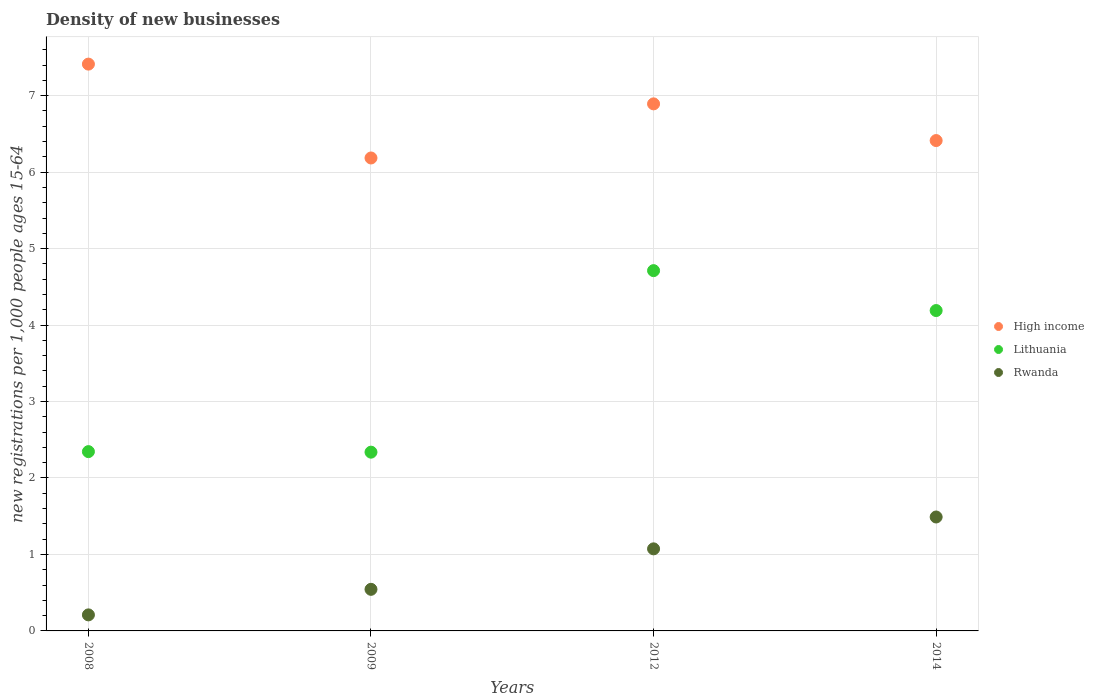How many different coloured dotlines are there?
Make the answer very short. 3. What is the number of new registrations in High income in 2008?
Provide a succinct answer. 7.41. Across all years, what is the maximum number of new registrations in Lithuania?
Make the answer very short. 4.71. Across all years, what is the minimum number of new registrations in High income?
Make the answer very short. 6.19. In which year was the number of new registrations in Rwanda minimum?
Your answer should be compact. 2008. What is the total number of new registrations in Lithuania in the graph?
Keep it short and to the point. 13.58. What is the difference between the number of new registrations in Lithuania in 2008 and that in 2012?
Your answer should be very brief. -2.37. What is the difference between the number of new registrations in Rwanda in 2014 and the number of new registrations in High income in 2009?
Offer a terse response. -4.7. What is the average number of new registrations in Lithuania per year?
Give a very brief answer. 3.4. In the year 2012, what is the difference between the number of new registrations in High income and number of new registrations in Lithuania?
Make the answer very short. 2.18. In how many years, is the number of new registrations in High income greater than 2.2?
Your answer should be compact. 4. What is the ratio of the number of new registrations in High income in 2008 to that in 2012?
Your response must be concise. 1.08. Is the number of new registrations in High income in 2009 less than that in 2014?
Provide a succinct answer. Yes. Is the difference between the number of new registrations in High income in 2009 and 2014 greater than the difference between the number of new registrations in Lithuania in 2009 and 2014?
Offer a very short reply. Yes. What is the difference between the highest and the second highest number of new registrations in Rwanda?
Provide a succinct answer. 0.42. What is the difference between the highest and the lowest number of new registrations in Rwanda?
Make the answer very short. 1.28. In how many years, is the number of new registrations in High income greater than the average number of new registrations in High income taken over all years?
Keep it short and to the point. 2. Is the sum of the number of new registrations in Lithuania in 2009 and 2014 greater than the maximum number of new registrations in High income across all years?
Provide a short and direct response. No. Is it the case that in every year, the sum of the number of new registrations in Lithuania and number of new registrations in High income  is greater than the number of new registrations in Rwanda?
Give a very brief answer. Yes. Does the number of new registrations in Rwanda monotonically increase over the years?
Your answer should be compact. Yes. Is the number of new registrations in High income strictly greater than the number of new registrations in Rwanda over the years?
Your answer should be compact. Yes. Is the number of new registrations in Rwanda strictly less than the number of new registrations in High income over the years?
Provide a short and direct response. Yes. How many dotlines are there?
Offer a terse response. 3. Does the graph contain any zero values?
Provide a short and direct response. No. Does the graph contain grids?
Offer a terse response. Yes. Where does the legend appear in the graph?
Provide a succinct answer. Center right. What is the title of the graph?
Keep it short and to the point. Density of new businesses. What is the label or title of the X-axis?
Keep it short and to the point. Years. What is the label or title of the Y-axis?
Ensure brevity in your answer.  New registrations per 1,0 people ages 15-64. What is the new registrations per 1,000 people ages 15-64 in High income in 2008?
Keep it short and to the point. 7.41. What is the new registrations per 1,000 people ages 15-64 in Lithuania in 2008?
Your response must be concise. 2.34. What is the new registrations per 1,000 people ages 15-64 of Rwanda in 2008?
Your response must be concise. 0.21. What is the new registrations per 1,000 people ages 15-64 in High income in 2009?
Make the answer very short. 6.19. What is the new registrations per 1,000 people ages 15-64 of Lithuania in 2009?
Your answer should be compact. 2.34. What is the new registrations per 1,000 people ages 15-64 in Rwanda in 2009?
Make the answer very short. 0.54. What is the new registrations per 1,000 people ages 15-64 of High income in 2012?
Keep it short and to the point. 6.89. What is the new registrations per 1,000 people ages 15-64 in Lithuania in 2012?
Make the answer very short. 4.71. What is the new registrations per 1,000 people ages 15-64 of Rwanda in 2012?
Ensure brevity in your answer.  1.07. What is the new registrations per 1,000 people ages 15-64 in High income in 2014?
Your response must be concise. 6.41. What is the new registrations per 1,000 people ages 15-64 of Lithuania in 2014?
Keep it short and to the point. 4.19. What is the new registrations per 1,000 people ages 15-64 in Rwanda in 2014?
Keep it short and to the point. 1.49. Across all years, what is the maximum new registrations per 1,000 people ages 15-64 of High income?
Give a very brief answer. 7.41. Across all years, what is the maximum new registrations per 1,000 people ages 15-64 in Lithuania?
Make the answer very short. 4.71. Across all years, what is the maximum new registrations per 1,000 people ages 15-64 of Rwanda?
Make the answer very short. 1.49. Across all years, what is the minimum new registrations per 1,000 people ages 15-64 in High income?
Provide a short and direct response. 6.19. Across all years, what is the minimum new registrations per 1,000 people ages 15-64 in Lithuania?
Provide a succinct answer. 2.34. Across all years, what is the minimum new registrations per 1,000 people ages 15-64 of Rwanda?
Make the answer very short. 0.21. What is the total new registrations per 1,000 people ages 15-64 in High income in the graph?
Offer a very short reply. 26.9. What is the total new registrations per 1,000 people ages 15-64 of Lithuania in the graph?
Give a very brief answer. 13.58. What is the total new registrations per 1,000 people ages 15-64 in Rwanda in the graph?
Offer a terse response. 3.32. What is the difference between the new registrations per 1,000 people ages 15-64 of High income in 2008 and that in 2009?
Keep it short and to the point. 1.23. What is the difference between the new registrations per 1,000 people ages 15-64 in Lithuania in 2008 and that in 2009?
Your answer should be very brief. 0.01. What is the difference between the new registrations per 1,000 people ages 15-64 in Rwanda in 2008 and that in 2009?
Provide a succinct answer. -0.33. What is the difference between the new registrations per 1,000 people ages 15-64 in High income in 2008 and that in 2012?
Your answer should be very brief. 0.52. What is the difference between the new registrations per 1,000 people ages 15-64 in Lithuania in 2008 and that in 2012?
Ensure brevity in your answer.  -2.37. What is the difference between the new registrations per 1,000 people ages 15-64 of Rwanda in 2008 and that in 2012?
Provide a short and direct response. -0.86. What is the difference between the new registrations per 1,000 people ages 15-64 of Lithuania in 2008 and that in 2014?
Provide a succinct answer. -1.84. What is the difference between the new registrations per 1,000 people ages 15-64 in Rwanda in 2008 and that in 2014?
Ensure brevity in your answer.  -1.28. What is the difference between the new registrations per 1,000 people ages 15-64 in High income in 2009 and that in 2012?
Keep it short and to the point. -0.71. What is the difference between the new registrations per 1,000 people ages 15-64 of Lithuania in 2009 and that in 2012?
Provide a short and direct response. -2.37. What is the difference between the new registrations per 1,000 people ages 15-64 in Rwanda in 2009 and that in 2012?
Ensure brevity in your answer.  -0.53. What is the difference between the new registrations per 1,000 people ages 15-64 in High income in 2009 and that in 2014?
Provide a short and direct response. -0.23. What is the difference between the new registrations per 1,000 people ages 15-64 in Lithuania in 2009 and that in 2014?
Offer a very short reply. -1.85. What is the difference between the new registrations per 1,000 people ages 15-64 of Rwanda in 2009 and that in 2014?
Keep it short and to the point. -0.95. What is the difference between the new registrations per 1,000 people ages 15-64 of High income in 2012 and that in 2014?
Your response must be concise. 0.48. What is the difference between the new registrations per 1,000 people ages 15-64 in Lithuania in 2012 and that in 2014?
Your answer should be compact. 0.52. What is the difference between the new registrations per 1,000 people ages 15-64 of Rwanda in 2012 and that in 2014?
Give a very brief answer. -0.42. What is the difference between the new registrations per 1,000 people ages 15-64 of High income in 2008 and the new registrations per 1,000 people ages 15-64 of Lithuania in 2009?
Your answer should be compact. 5.08. What is the difference between the new registrations per 1,000 people ages 15-64 in High income in 2008 and the new registrations per 1,000 people ages 15-64 in Rwanda in 2009?
Provide a short and direct response. 6.87. What is the difference between the new registrations per 1,000 people ages 15-64 of Lithuania in 2008 and the new registrations per 1,000 people ages 15-64 of Rwanda in 2009?
Offer a terse response. 1.8. What is the difference between the new registrations per 1,000 people ages 15-64 in High income in 2008 and the new registrations per 1,000 people ages 15-64 in Lithuania in 2012?
Keep it short and to the point. 2.7. What is the difference between the new registrations per 1,000 people ages 15-64 in High income in 2008 and the new registrations per 1,000 people ages 15-64 in Rwanda in 2012?
Keep it short and to the point. 6.34. What is the difference between the new registrations per 1,000 people ages 15-64 in Lithuania in 2008 and the new registrations per 1,000 people ages 15-64 in Rwanda in 2012?
Offer a very short reply. 1.27. What is the difference between the new registrations per 1,000 people ages 15-64 of High income in 2008 and the new registrations per 1,000 people ages 15-64 of Lithuania in 2014?
Keep it short and to the point. 3.22. What is the difference between the new registrations per 1,000 people ages 15-64 of High income in 2008 and the new registrations per 1,000 people ages 15-64 of Rwanda in 2014?
Your response must be concise. 5.92. What is the difference between the new registrations per 1,000 people ages 15-64 in Lithuania in 2008 and the new registrations per 1,000 people ages 15-64 in Rwanda in 2014?
Your answer should be compact. 0.85. What is the difference between the new registrations per 1,000 people ages 15-64 in High income in 2009 and the new registrations per 1,000 people ages 15-64 in Lithuania in 2012?
Your answer should be very brief. 1.47. What is the difference between the new registrations per 1,000 people ages 15-64 of High income in 2009 and the new registrations per 1,000 people ages 15-64 of Rwanda in 2012?
Keep it short and to the point. 5.11. What is the difference between the new registrations per 1,000 people ages 15-64 in Lithuania in 2009 and the new registrations per 1,000 people ages 15-64 in Rwanda in 2012?
Keep it short and to the point. 1.26. What is the difference between the new registrations per 1,000 people ages 15-64 of High income in 2009 and the new registrations per 1,000 people ages 15-64 of Lithuania in 2014?
Your response must be concise. 2. What is the difference between the new registrations per 1,000 people ages 15-64 in High income in 2009 and the new registrations per 1,000 people ages 15-64 in Rwanda in 2014?
Offer a very short reply. 4.7. What is the difference between the new registrations per 1,000 people ages 15-64 in Lithuania in 2009 and the new registrations per 1,000 people ages 15-64 in Rwanda in 2014?
Offer a very short reply. 0.85. What is the difference between the new registrations per 1,000 people ages 15-64 of High income in 2012 and the new registrations per 1,000 people ages 15-64 of Lithuania in 2014?
Your answer should be compact. 2.7. What is the difference between the new registrations per 1,000 people ages 15-64 in High income in 2012 and the new registrations per 1,000 people ages 15-64 in Rwanda in 2014?
Keep it short and to the point. 5.4. What is the difference between the new registrations per 1,000 people ages 15-64 in Lithuania in 2012 and the new registrations per 1,000 people ages 15-64 in Rwanda in 2014?
Your answer should be very brief. 3.22. What is the average new registrations per 1,000 people ages 15-64 in High income per year?
Keep it short and to the point. 6.73. What is the average new registrations per 1,000 people ages 15-64 in Lithuania per year?
Your response must be concise. 3.4. What is the average new registrations per 1,000 people ages 15-64 of Rwanda per year?
Keep it short and to the point. 0.83. In the year 2008, what is the difference between the new registrations per 1,000 people ages 15-64 of High income and new registrations per 1,000 people ages 15-64 of Lithuania?
Ensure brevity in your answer.  5.07. In the year 2008, what is the difference between the new registrations per 1,000 people ages 15-64 in High income and new registrations per 1,000 people ages 15-64 in Rwanda?
Offer a terse response. 7.2. In the year 2008, what is the difference between the new registrations per 1,000 people ages 15-64 of Lithuania and new registrations per 1,000 people ages 15-64 of Rwanda?
Your answer should be very brief. 2.14. In the year 2009, what is the difference between the new registrations per 1,000 people ages 15-64 in High income and new registrations per 1,000 people ages 15-64 in Lithuania?
Ensure brevity in your answer.  3.85. In the year 2009, what is the difference between the new registrations per 1,000 people ages 15-64 in High income and new registrations per 1,000 people ages 15-64 in Rwanda?
Offer a terse response. 5.64. In the year 2009, what is the difference between the new registrations per 1,000 people ages 15-64 in Lithuania and new registrations per 1,000 people ages 15-64 in Rwanda?
Make the answer very short. 1.79. In the year 2012, what is the difference between the new registrations per 1,000 people ages 15-64 of High income and new registrations per 1,000 people ages 15-64 of Lithuania?
Your response must be concise. 2.18. In the year 2012, what is the difference between the new registrations per 1,000 people ages 15-64 in High income and new registrations per 1,000 people ages 15-64 in Rwanda?
Give a very brief answer. 5.82. In the year 2012, what is the difference between the new registrations per 1,000 people ages 15-64 of Lithuania and new registrations per 1,000 people ages 15-64 of Rwanda?
Offer a very short reply. 3.64. In the year 2014, what is the difference between the new registrations per 1,000 people ages 15-64 of High income and new registrations per 1,000 people ages 15-64 of Lithuania?
Offer a very short reply. 2.22. In the year 2014, what is the difference between the new registrations per 1,000 people ages 15-64 of High income and new registrations per 1,000 people ages 15-64 of Rwanda?
Keep it short and to the point. 4.92. In the year 2014, what is the difference between the new registrations per 1,000 people ages 15-64 in Lithuania and new registrations per 1,000 people ages 15-64 in Rwanda?
Your answer should be very brief. 2.7. What is the ratio of the new registrations per 1,000 people ages 15-64 in High income in 2008 to that in 2009?
Your answer should be compact. 1.2. What is the ratio of the new registrations per 1,000 people ages 15-64 of Lithuania in 2008 to that in 2009?
Provide a short and direct response. 1. What is the ratio of the new registrations per 1,000 people ages 15-64 of Rwanda in 2008 to that in 2009?
Your answer should be very brief. 0.39. What is the ratio of the new registrations per 1,000 people ages 15-64 in High income in 2008 to that in 2012?
Your answer should be very brief. 1.08. What is the ratio of the new registrations per 1,000 people ages 15-64 in Lithuania in 2008 to that in 2012?
Your answer should be compact. 0.5. What is the ratio of the new registrations per 1,000 people ages 15-64 in Rwanda in 2008 to that in 2012?
Provide a succinct answer. 0.2. What is the ratio of the new registrations per 1,000 people ages 15-64 of High income in 2008 to that in 2014?
Your answer should be very brief. 1.16. What is the ratio of the new registrations per 1,000 people ages 15-64 in Lithuania in 2008 to that in 2014?
Provide a succinct answer. 0.56. What is the ratio of the new registrations per 1,000 people ages 15-64 in Rwanda in 2008 to that in 2014?
Keep it short and to the point. 0.14. What is the ratio of the new registrations per 1,000 people ages 15-64 in High income in 2009 to that in 2012?
Provide a short and direct response. 0.9. What is the ratio of the new registrations per 1,000 people ages 15-64 in Lithuania in 2009 to that in 2012?
Provide a short and direct response. 0.5. What is the ratio of the new registrations per 1,000 people ages 15-64 in Rwanda in 2009 to that in 2012?
Make the answer very short. 0.51. What is the ratio of the new registrations per 1,000 people ages 15-64 of High income in 2009 to that in 2014?
Offer a terse response. 0.96. What is the ratio of the new registrations per 1,000 people ages 15-64 in Lithuania in 2009 to that in 2014?
Provide a short and direct response. 0.56. What is the ratio of the new registrations per 1,000 people ages 15-64 in Rwanda in 2009 to that in 2014?
Ensure brevity in your answer.  0.37. What is the ratio of the new registrations per 1,000 people ages 15-64 of High income in 2012 to that in 2014?
Ensure brevity in your answer.  1.07. What is the ratio of the new registrations per 1,000 people ages 15-64 of Lithuania in 2012 to that in 2014?
Your answer should be very brief. 1.12. What is the ratio of the new registrations per 1,000 people ages 15-64 in Rwanda in 2012 to that in 2014?
Keep it short and to the point. 0.72. What is the difference between the highest and the second highest new registrations per 1,000 people ages 15-64 of High income?
Offer a terse response. 0.52. What is the difference between the highest and the second highest new registrations per 1,000 people ages 15-64 in Lithuania?
Your response must be concise. 0.52. What is the difference between the highest and the second highest new registrations per 1,000 people ages 15-64 in Rwanda?
Your answer should be very brief. 0.42. What is the difference between the highest and the lowest new registrations per 1,000 people ages 15-64 of High income?
Provide a short and direct response. 1.23. What is the difference between the highest and the lowest new registrations per 1,000 people ages 15-64 in Lithuania?
Offer a terse response. 2.37. What is the difference between the highest and the lowest new registrations per 1,000 people ages 15-64 in Rwanda?
Keep it short and to the point. 1.28. 